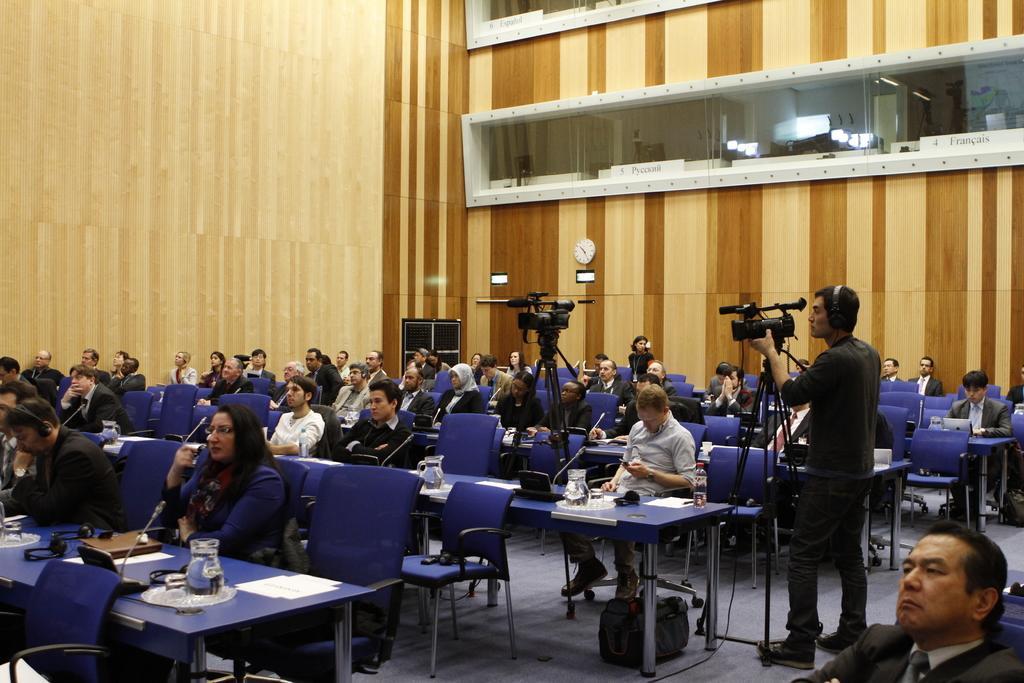How would you summarize this image in a sentence or two? The picture is taken in a big hall where number of people are sitting on the chairs and at the right corner of the picture there is one person standing and holding a camera in front of him and wearing headphones he is in black dress and in front him another person is sitting and watching a mobile phone. In Front of the people there are tables where waterjars and books and headphones are present and behind the people there is a big wall and on the wall there is a clock and at the middle of the picture there is a big speaker and a big glass window on the wall. 